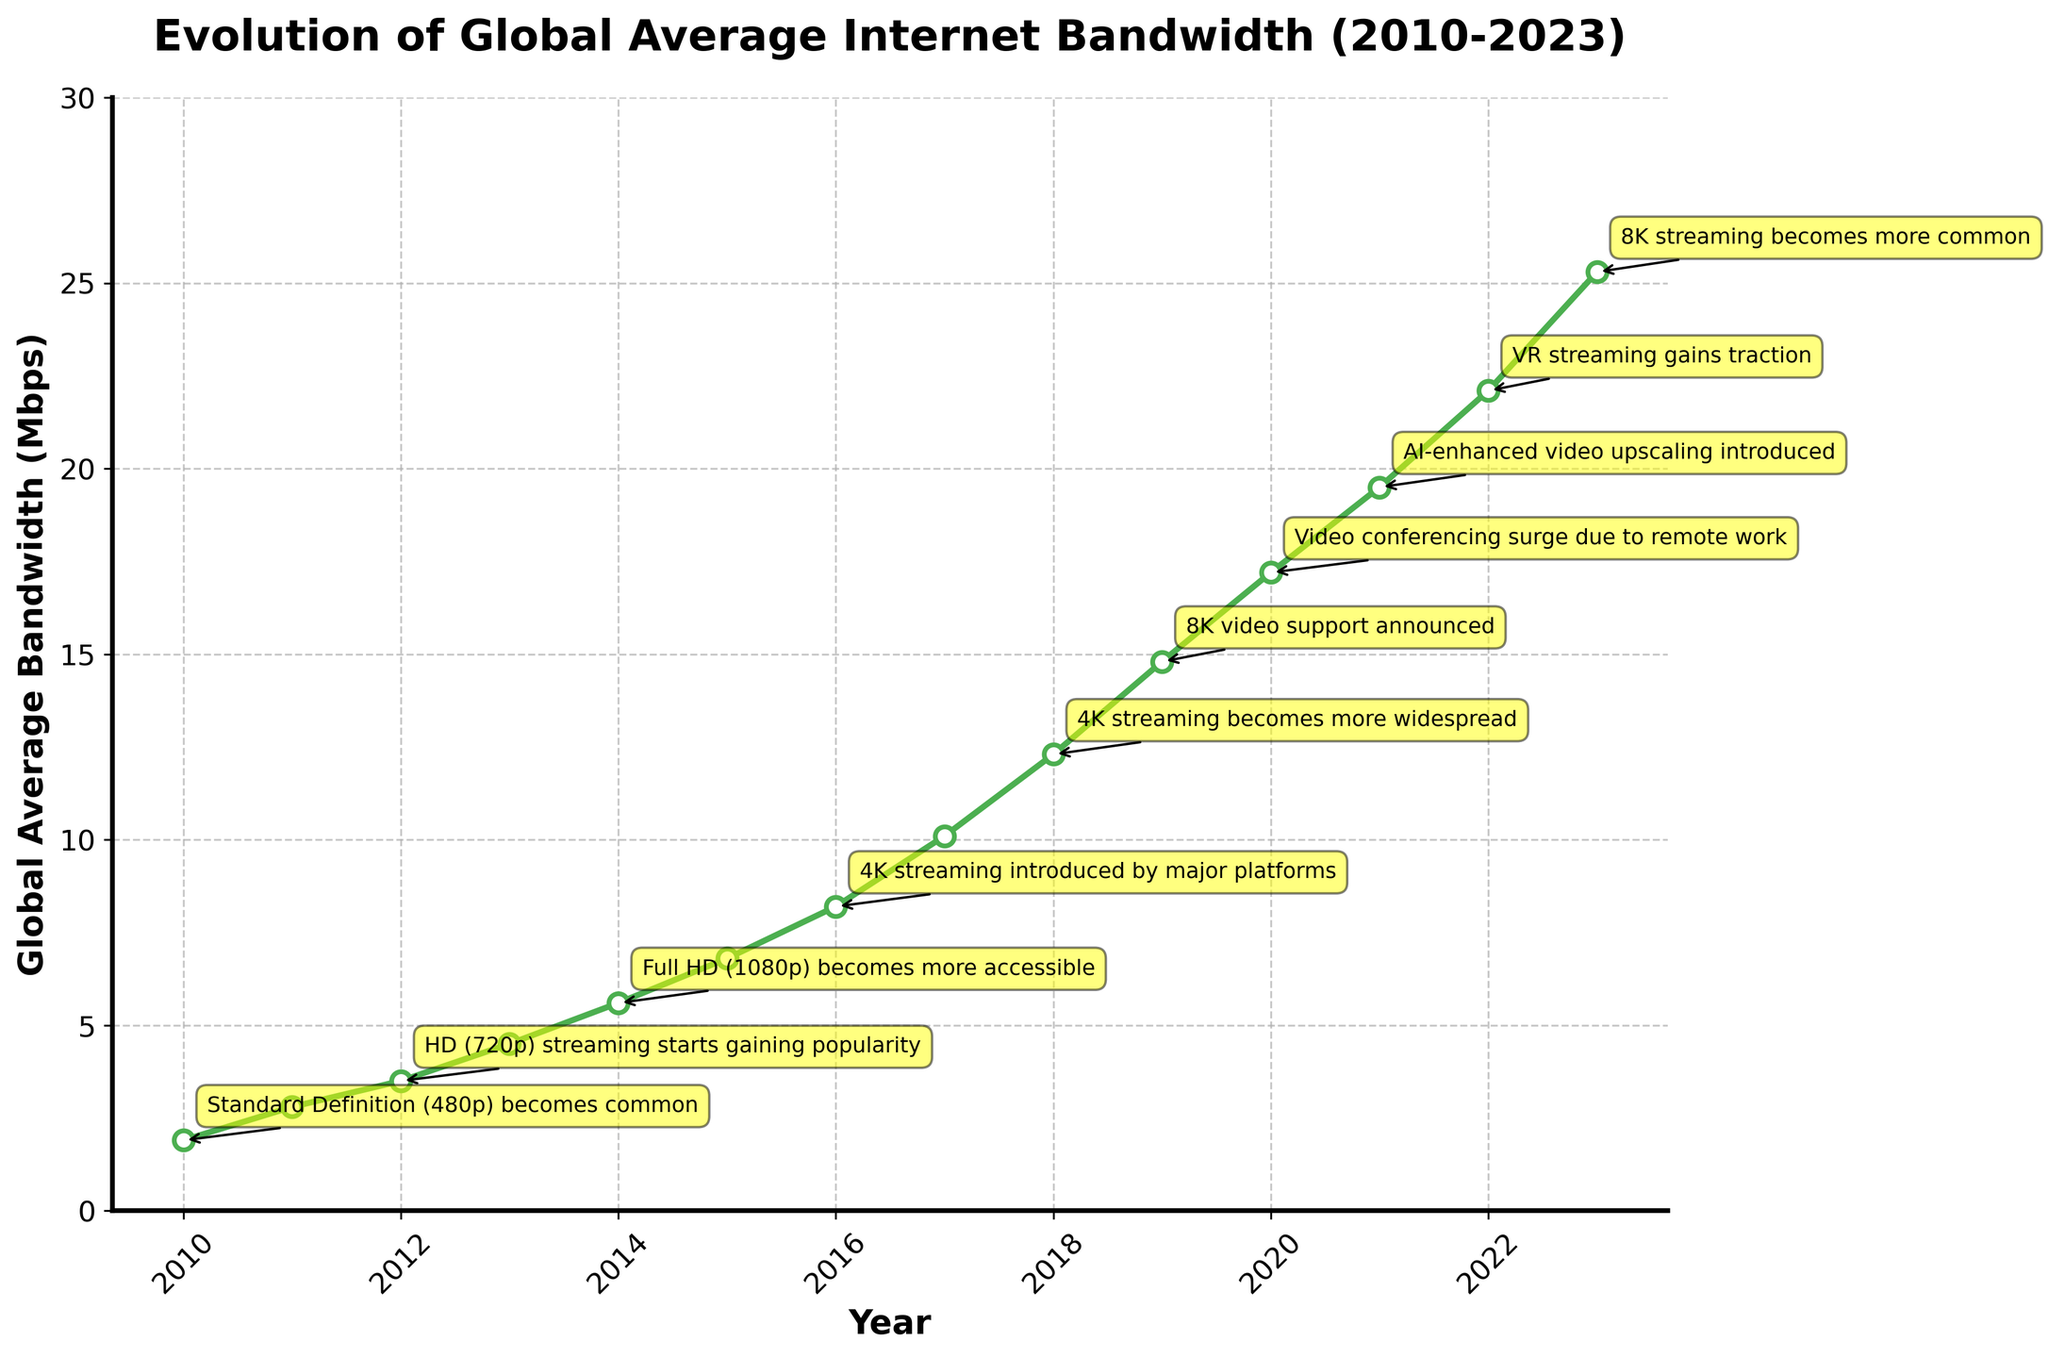What's the bandwidth speed in 2020? The bandwidth speed can be found directly from the y-axis value corresponding to the year 2020 on the x-axis.
Answer: 17.2 Mbps Which year did 4K streaming become more widespread? We need to look for the annotation that mentions "4K streaming becomes more widespread". From the figure, it's noted on the year 2018.
Answer: 2018 How does the bandwidth speed in 2013 compare to that in 2015? From the plotted line, find the y-axis values for the years 2013 and 2015. The bandwidth speed in 2013 is 4.5 Mbps and in 2015 it is 6.8 Mbps. Thus, 2015 is higher.
Answer: 2015 is higher What is the average bandwidth speed between 2010 and 2013 inclusive? Calculate the sum of the bandwidth speeds from 2010 to 2013 and divide by the number of years. (1.9+2.8+3.5+4.5) / 4 = 3.175 Mbps
Answer: 3.175 Mbps What milestone was achieved in 2023? Look at the annotation on the figure for the year 2023. It mentions "8K streaming becomes more common".
Answer: 8K streaming becomes more common In which year was the bandwidth speed first recorded to be above 10 Mbps? Identify the first year when the y-axis value (bandwidth) crosses above 10 Mbps. This happens in 2017.
Answer: 2017 How much did the bandwidth speed increase from 2014 to 2015? Subtract the 2014 bandwidth speed from the 2015 bandwidth speed. (6.8 - 5.6) = 1.2 Mbps
Answer: 1.2 Mbps Which two consecutive years have the largest increase in bandwidth speed? Calculate the differences between each consecutive year's bandwidth speed and compare them. The largest increase is from 2018 (12.3) to 2019 (14.8), which equals 2.5 Mbps.
Answer: 2018 to 2019 What visual attribute signals a milestone in the figure? Milestones are indicated by yellow-colored annotations with directional arrows pointing to the corresponding year and bandwidth speed on the chart.
Answer: Yellow annotations with arrows What's the total number of video streaming quality milestones annotated from 2010 to 2023? Count the number of milestone annotations displayed on the figure. There are 11 milestones annotated according to the figure.
Answer: 11 